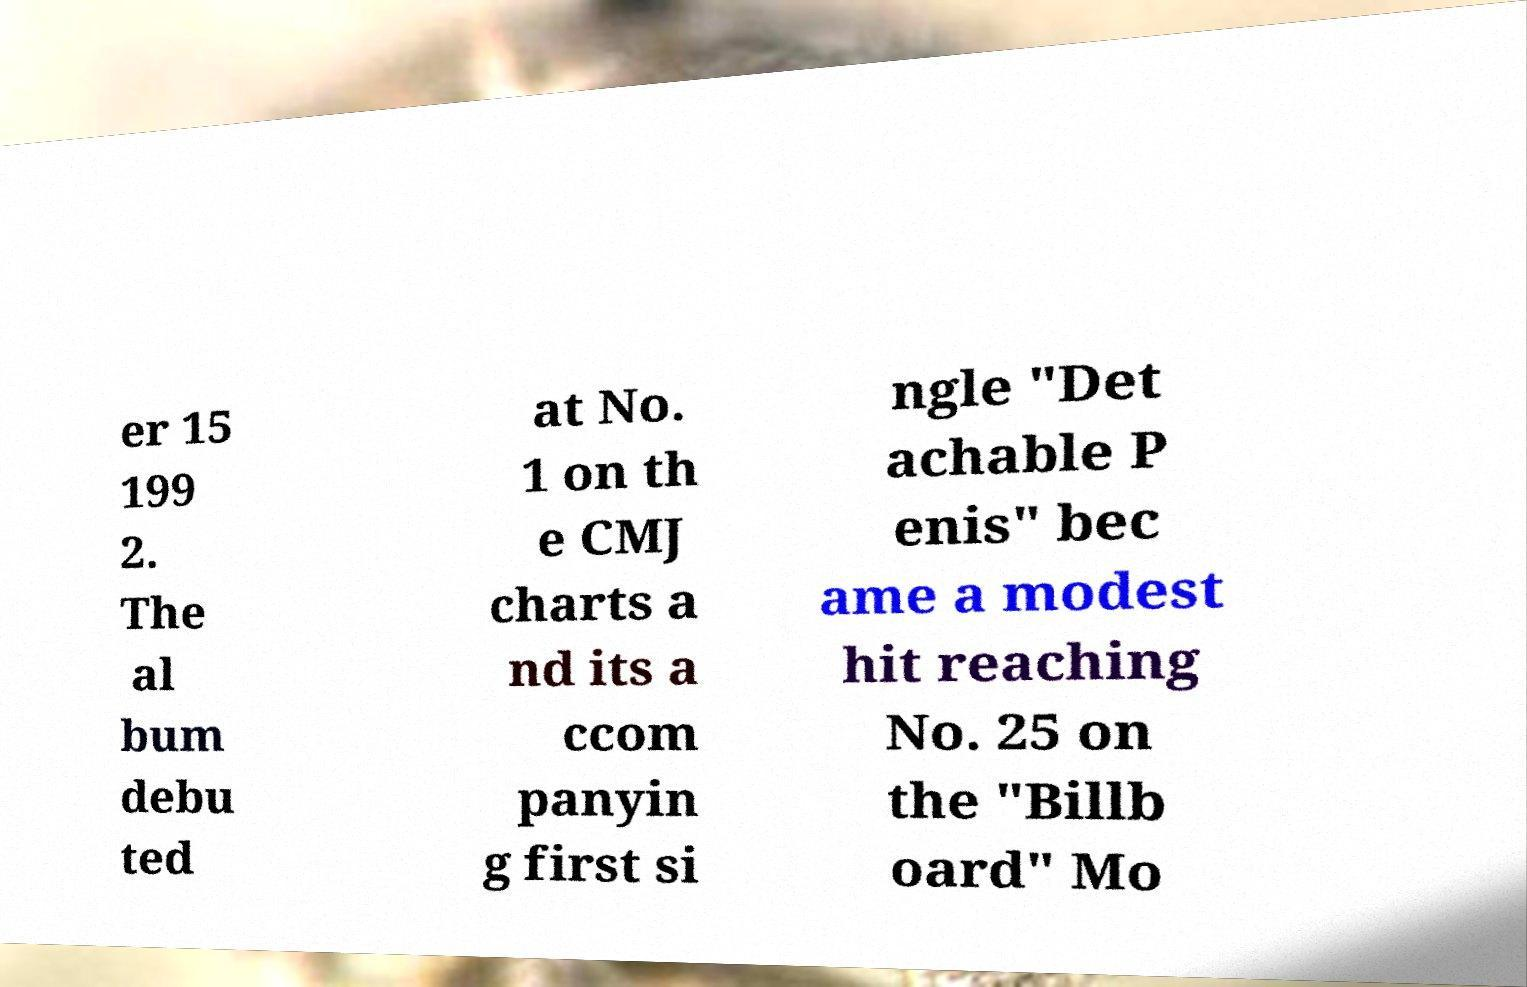For documentation purposes, I need the text within this image transcribed. Could you provide that? er 15 199 2. The al bum debu ted at No. 1 on th e CMJ charts a nd its a ccom panyin g first si ngle "Det achable P enis" bec ame a modest hit reaching No. 25 on the "Billb oard" Mo 